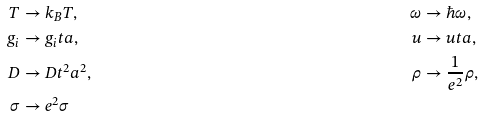Convert formula to latex. <formula><loc_0><loc_0><loc_500><loc_500>T & \rightarrow k _ { B } T , & \omega & \rightarrow \hbar { \omega } , \\ g _ { i } & \rightarrow g _ { i } t a , & u & \rightarrow u t a , \\ D & \rightarrow D t ^ { 2 } a ^ { 2 } , & \rho & \rightarrow \frac { 1 } { e ^ { 2 } } \rho , \\ \sigma & \rightarrow e ^ { 2 } \sigma</formula> 